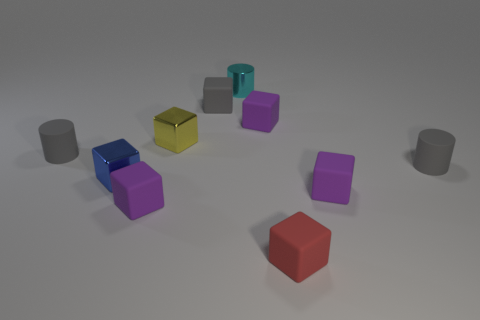Are all the objects in the image some type of geometric shape? Yes, all the objects in the image are geometric shapes. There are cubes, which have six square faces, and cylinders, which have circular faces and curved surfaces. How many cylinders are there, and do they share the same color? There are five cylinders in the image, and they don't all share the same color. The cylinders come in different shades, including gray, purple, and teal. 